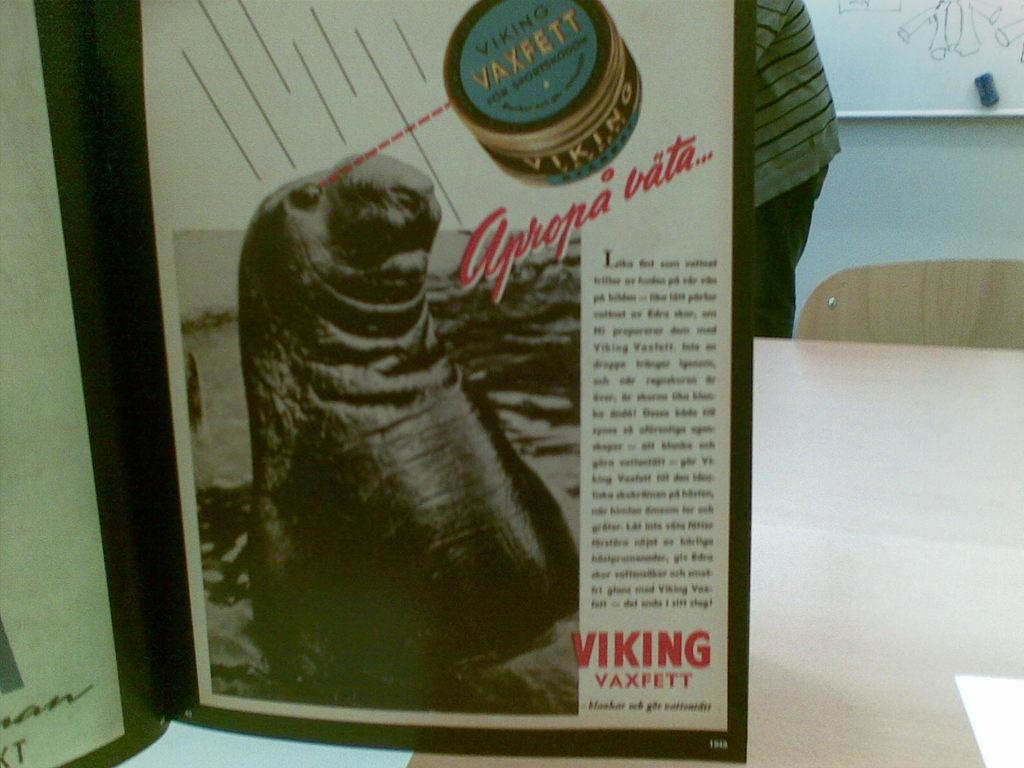Provide a one-sentence caption for the provided image. An advertisement for Viking Vaxfett shows some kind of seal or sea lion. 